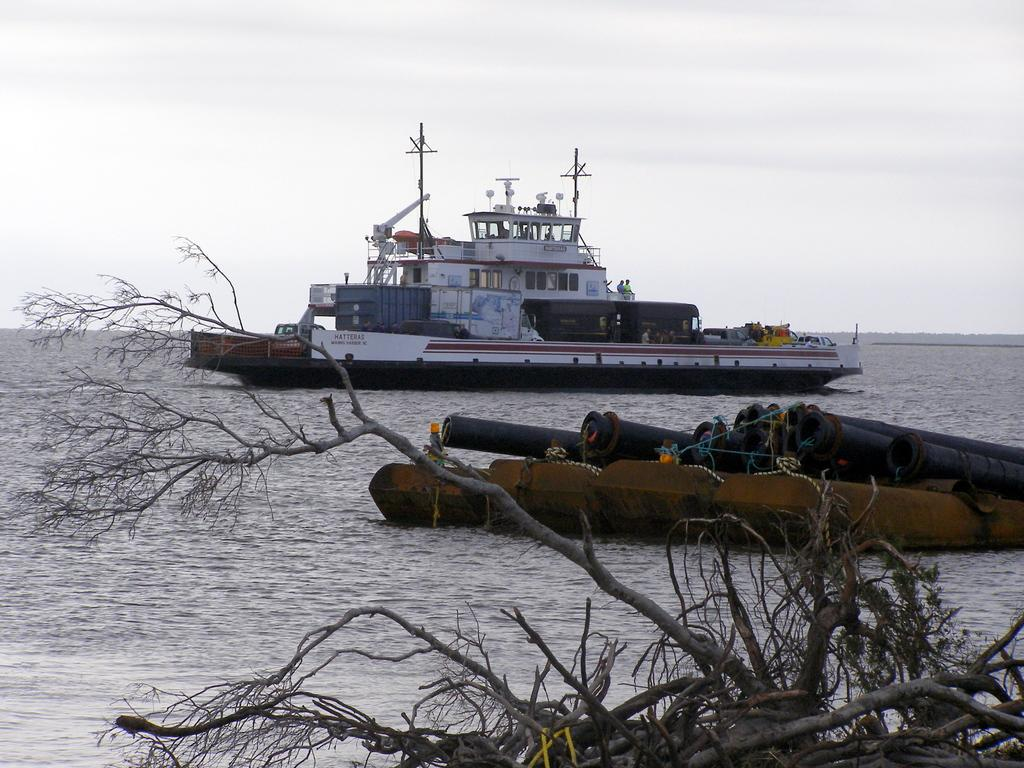What is the main subject of the image? The main subject of the image is a ship. What is located at the bottom of the image? There is water at the bottom of the image. What type of vegetation can be seen in the image? Dried plants are visible in the image. What can be seen in the middle of the image? There are pipes in the middle of the image. What type of zipper can be seen on the ship in the image? There is no zipper present on the ship in the image. How many balls are visible in the image? There are no balls visible in the image. 